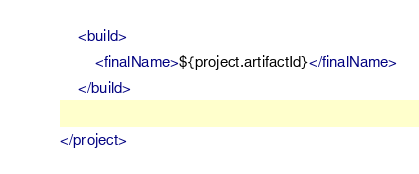Convert code to text. <code><loc_0><loc_0><loc_500><loc_500><_XML_>
    <build>
        <finalName>${project.artifactId}</finalName>
    </build>

</project>
</code> 